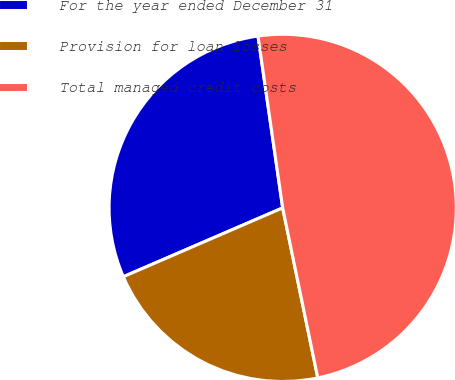<chart> <loc_0><loc_0><loc_500><loc_500><pie_chart><fcel>For the year ended December 31<fcel>Provision for loan losses<fcel>Total managed credit costs<nl><fcel>29.22%<fcel>21.75%<fcel>49.03%<nl></chart> 